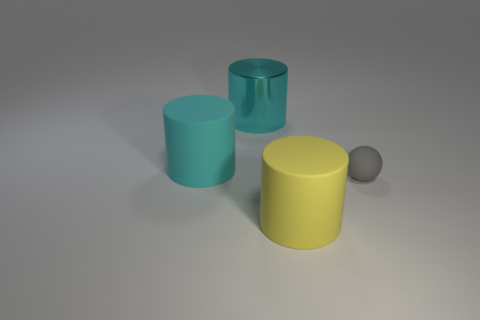Does the big matte thing on the right side of the large cyan metallic cylinder have the same shape as the tiny rubber object? No, they do not have the same shape. The larger matte object on the right appears to be a cylinder, similar in shape to the cyan metallic cylinder, but the tiny object has a spherical shape. 